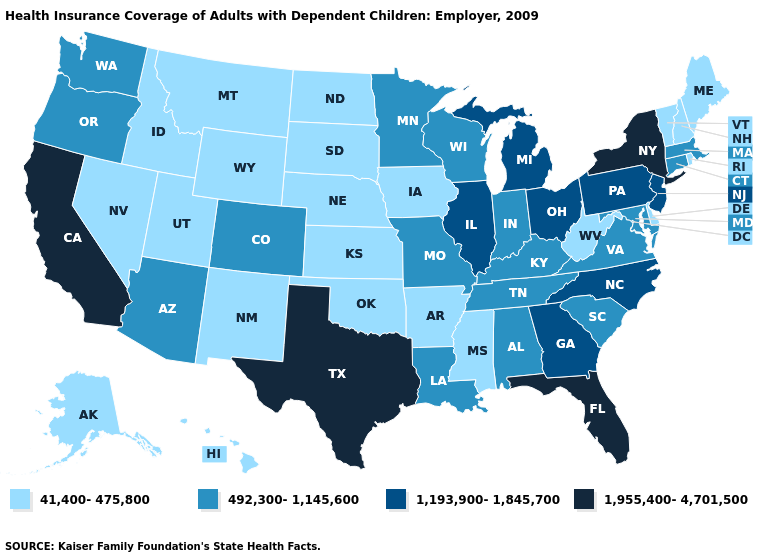Does Texas have the highest value in the USA?
Keep it brief. Yes. What is the value of Connecticut?
Concise answer only. 492,300-1,145,600. Among the states that border Wisconsin , does Illinois have the highest value?
Keep it brief. Yes. Among the states that border Mississippi , which have the lowest value?
Be succinct. Arkansas. What is the value of Mississippi?
Keep it brief. 41,400-475,800. What is the lowest value in states that border South Dakota?
Write a very short answer. 41,400-475,800. What is the lowest value in states that border Oregon?
Short answer required. 41,400-475,800. Does the first symbol in the legend represent the smallest category?
Give a very brief answer. Yes. Name the states that have a value in the range 1,193,900-1,845,700?
Be succinct. Georgia, Illinois, Michigan, New Jersey, North Carolina, Ohio, Pennsylvania. Among the states that border Kansas , does Oklahoma have the lowest value?
Give a very brief answer. Yes. Does Utah have the highest value in the West?
Quick response, please. No. Among the states that border Kansas , which have the lowest value?
Give a very brief answer. Nebraska, Oklahoma. What is the lowest value in states that border New Jersey?
Write a very short answer. 41,400-475,800. Does Washington have a higher value than Montana?
Quick response, please. Yes. Is the legend a continuous bar?
Keep it brief. No. 